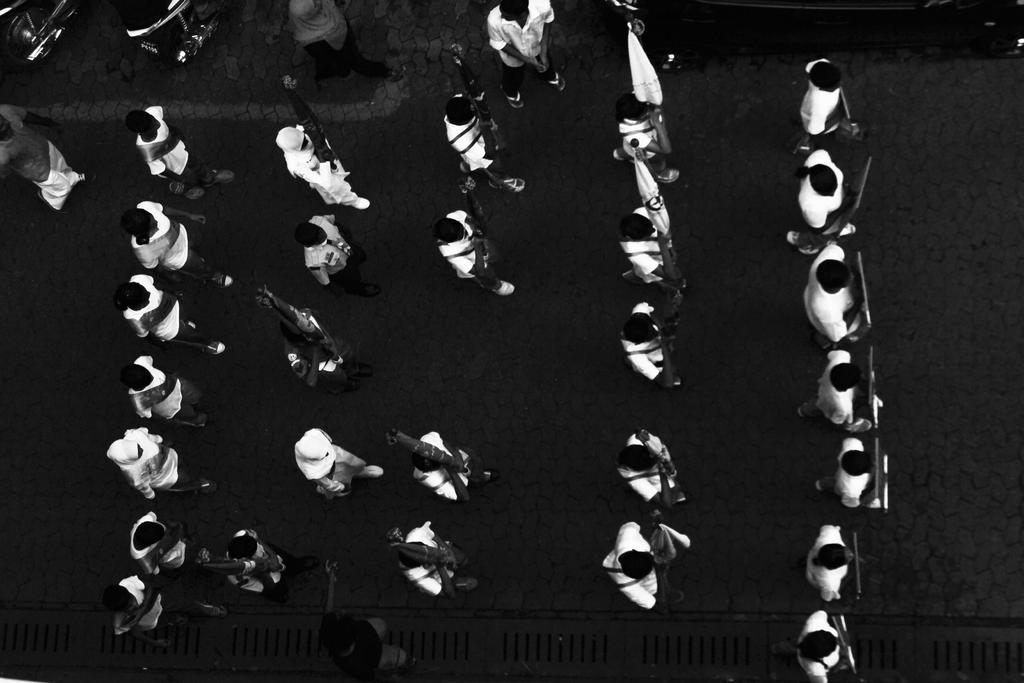Please provide a concise description of this image. In this image we can see people walking on the road holding placards,flags. 